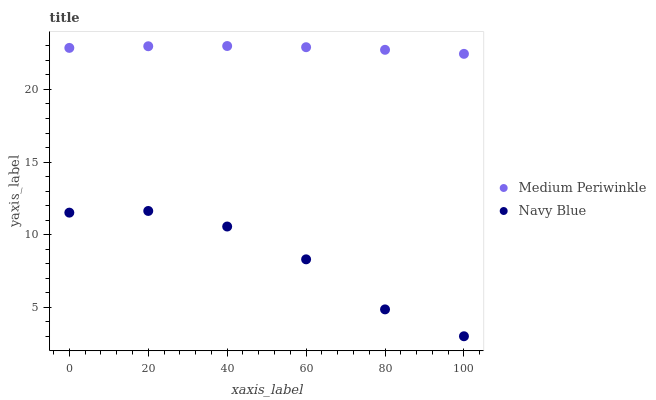Does Navy Blue have the minimum area under the curve?
Answer yes or no. Yes. Does Medium Periwinkle have the maximum area under the curve?
Answer yes or no. Yes. Does Medium Periwinkle have the minimum area under the curve?
Answer yes or no. No. Is Medium Periwinkle the smoothest?
Answer yes or no. Yes. Is Navy Blue the roughest?
Answer yes or no. Yes. Is Medium Periwinkle the roughest?
Answer yes or no. No. Does Navy Blue have the lowest value?
Answer yes or no. Yes. Does Medium Periwinkle have the lowest value?
Answer yes or no. No. Does Medium Periwinkle have the highest value?
Answer yes or no. Yes. Is Navy Blue less than Medium Periwinkle?
Answer yes or no. Yes. Is Medium Periwinkle greater than Navy Blue?
Answer yes or no. Yes. Does Navy Blue intersect Medium Periwinkle?
Answer yes or no. No. 